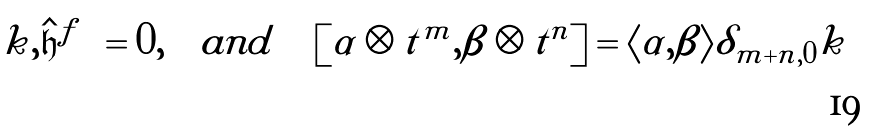<formula> <loc_0><loc_0><loc_500><loc_500>\left [ k , \hat { \mathfrak { h } } ^ { f } \right ] = 0 , \quad a n d \quad \left [ \alpha \otimes t ^ { m } , \beta \otimes t ^ { n } \right ] = \langle \alpha , \beta \rangle \delta _ { m + n , 0 } k</formula> 